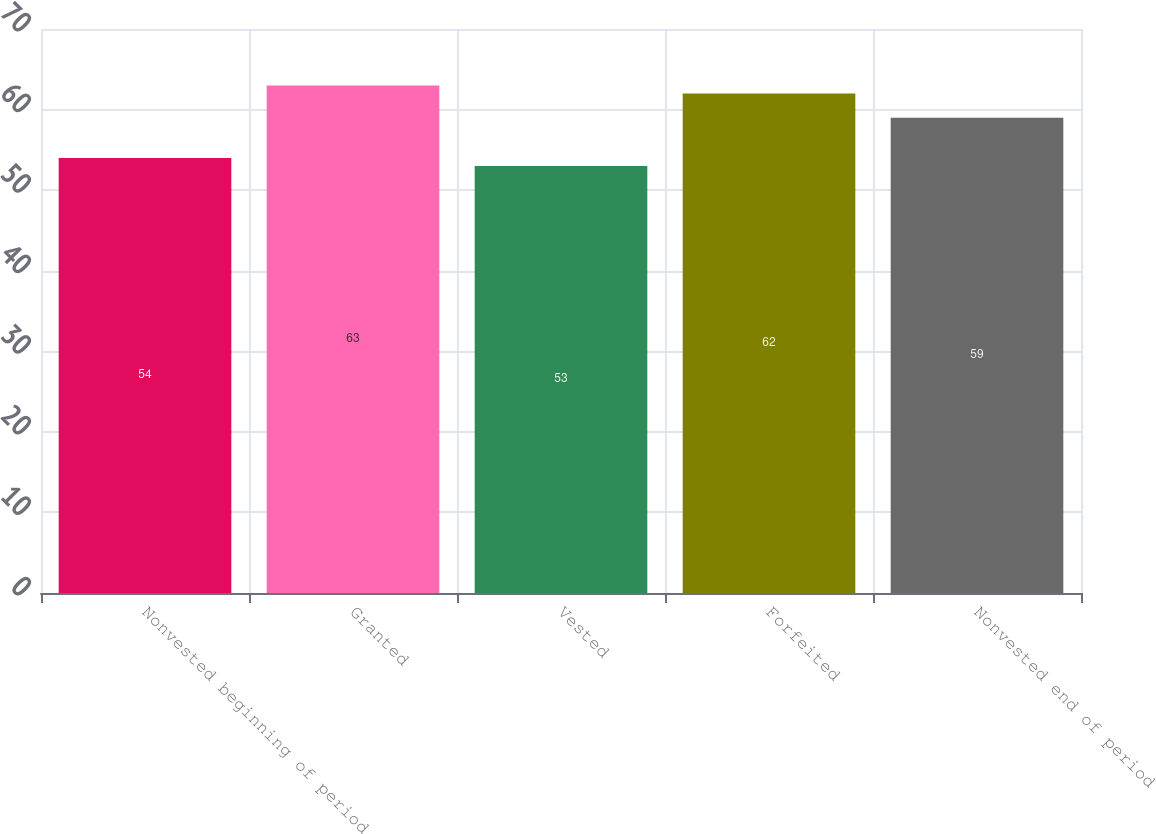Convert chart to OTSL. <chart><loc_0><loc_0><loc_500><loc_500><bar_chart><fcel>Nonvested beginning of period<fcel>Granted<fcel>Vested<fcel>Forfeited<fcel>Nonvested end of period<nl><fcel>54<fcel>63<fcel>53<fcel>62<fcel>59<nl></chart> 